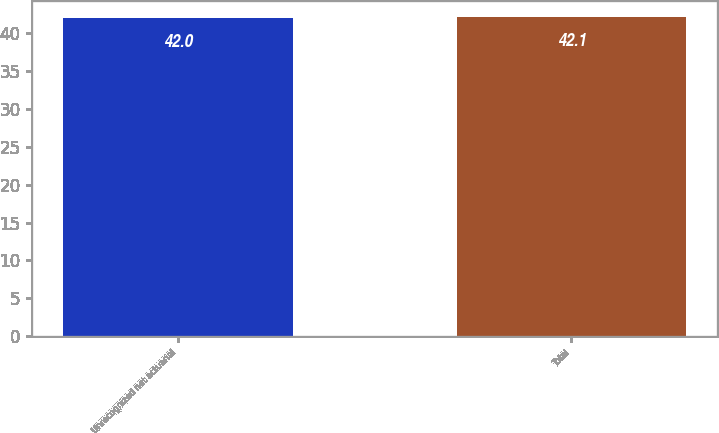Convert chart to OTSL. <chart><loc_0><loc_0><loc_500><loc_500><bar_chart><fcel>Unrecognized net actuarial<fcel>Total<nl><fcel>42<fcel>42.1<nl></chart> 